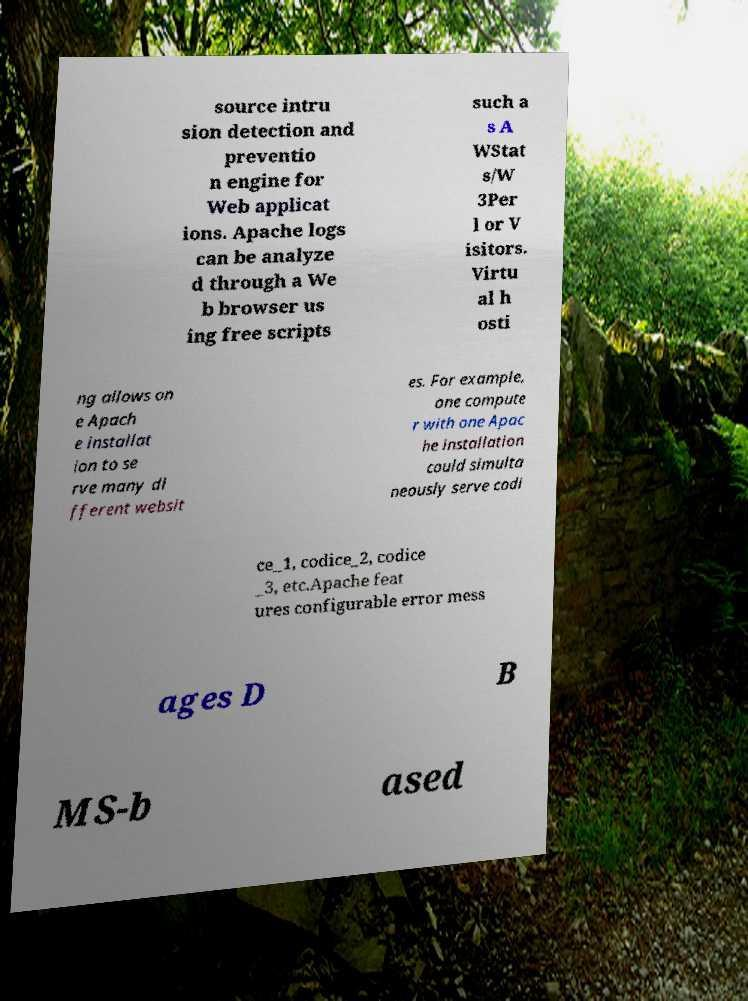Please identify and transcribe the text found in this image. source intru sion detection and preventio n engine for Web applicat ions. Apache logs can be analyze d through a We b browser us ing free scripts such a s A WStat s/W 3Per l or V isitors. Virtu al h osti ng allows on e Apach e installat ion to se rve many di fferent websit es. For example, one compute r with one Apac he installation could simulta neously serve codi ce_1, codice_2, codice _3, etc.Apache feat ures configurable error mess ages D B MS-b ased 